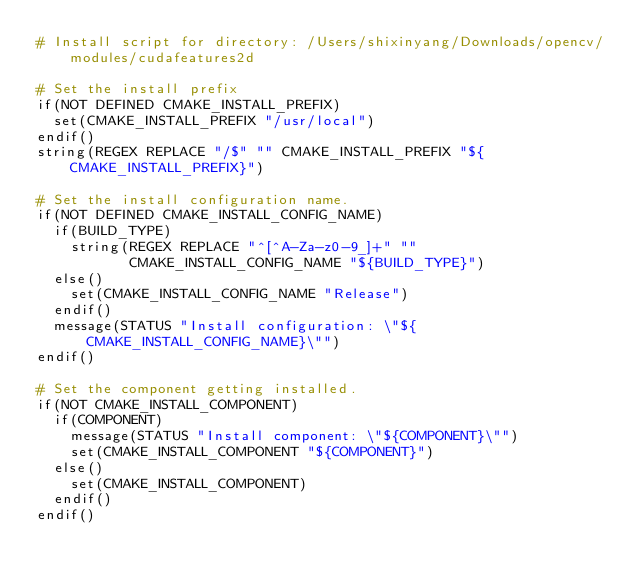<code> <loc_0><loc_0><loc_500><loc_500><_CMake_># Install script for directory: /Users/shixinyang/Downloads/opencv/modules/cudafeatures2d

# Set the install prefix
if(NOT DEFINED CMAKE_INSTALL_PREFIX)
  set(CMAKE_INSTALL_PREFIX "/usr/local")
endif()
string(REGEX REPLACE "/$" "" CMAKE_INSTALL_PREFIX "${CMAKE_INSTALL_PREFIX}")

# Set the install configuration name.
if(NOT DEFINED CMAKE_INSTALL_CONFIG_NAME)
  if(BUILD_TYPE)
    string(REGEX REPLACE "^[^A-Za-z0-9_]+" ""
           CMAKE_INSTALL_CONFIG_NAME "${BUILD_TYPE}")
  else()
    set(CMAKE_INSTALL_CONFIG_NAME "Release")
  endif()
  message(STATUS "Install configuration: \"${CMAKE_INSTALL_CONFIG_NAME}\"")
endif()

# Set the component getting installed.
if(NOT CMAKE_INSTALL_COMPONENT)
  if(COMPONENT)
    message(STATUS "Install component: \"${COMPONENT}\"")
    set(CMAKE_INSTALL_COMPONENT "${COMPONENT}")
  else()
    set(CMAKE_INSTALL_COMPONENT)
  endif()
endif()

</code> 